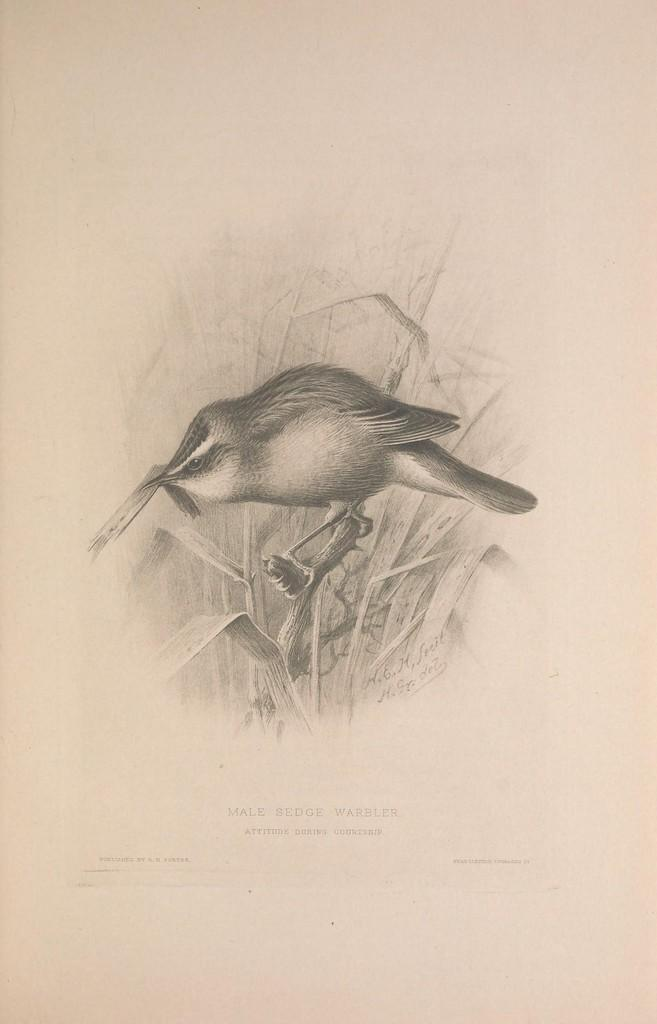What type of animal can be seen in the image? There is a bird in the image. Where is the bird located? The bird is on a branch. What is the medium of the image? The image is a printed paper. What else can be seen on the paper besides the bird? There is text visible on the paper. What type of cracker is the bird holding in its beak in the image? There is no cracker present in the image; the bird is on a branch, and there is no indication of it holding any object. 